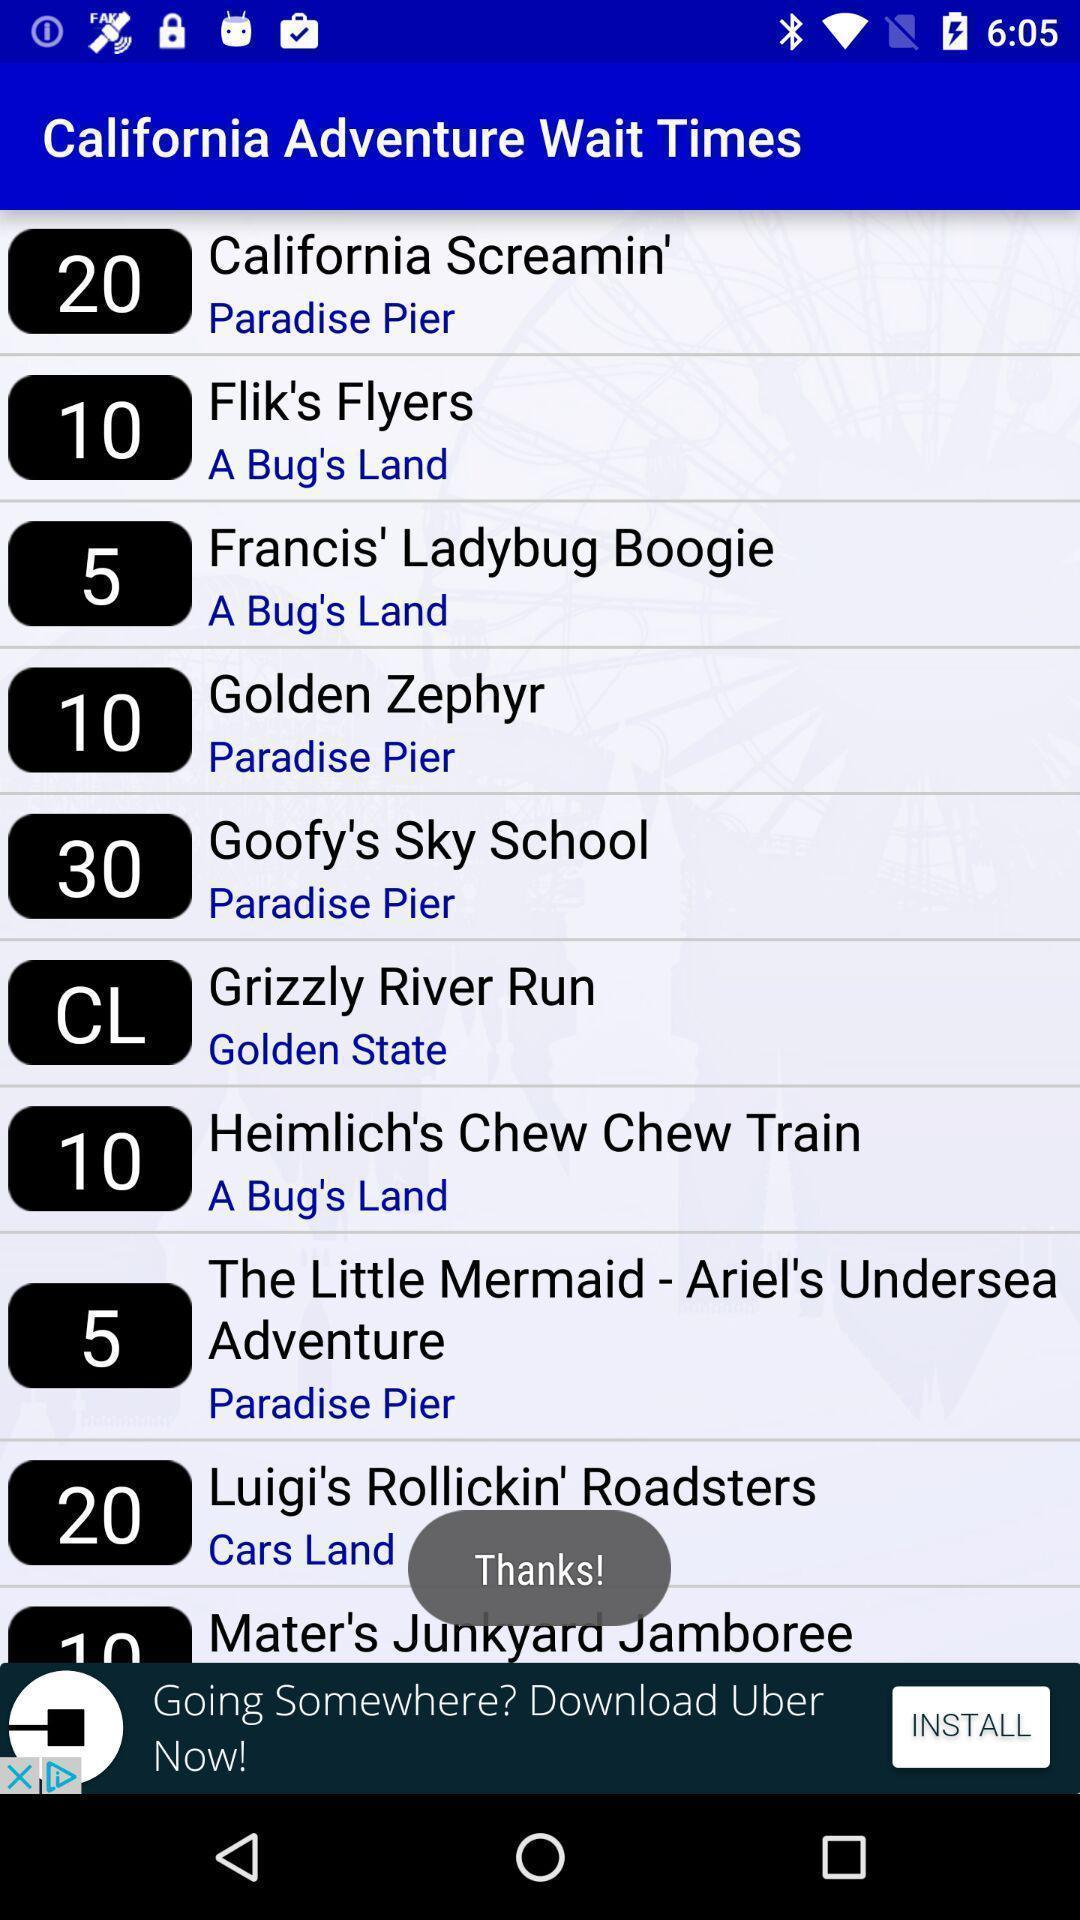Provide a description of this screenshot. Page showing list of places. 